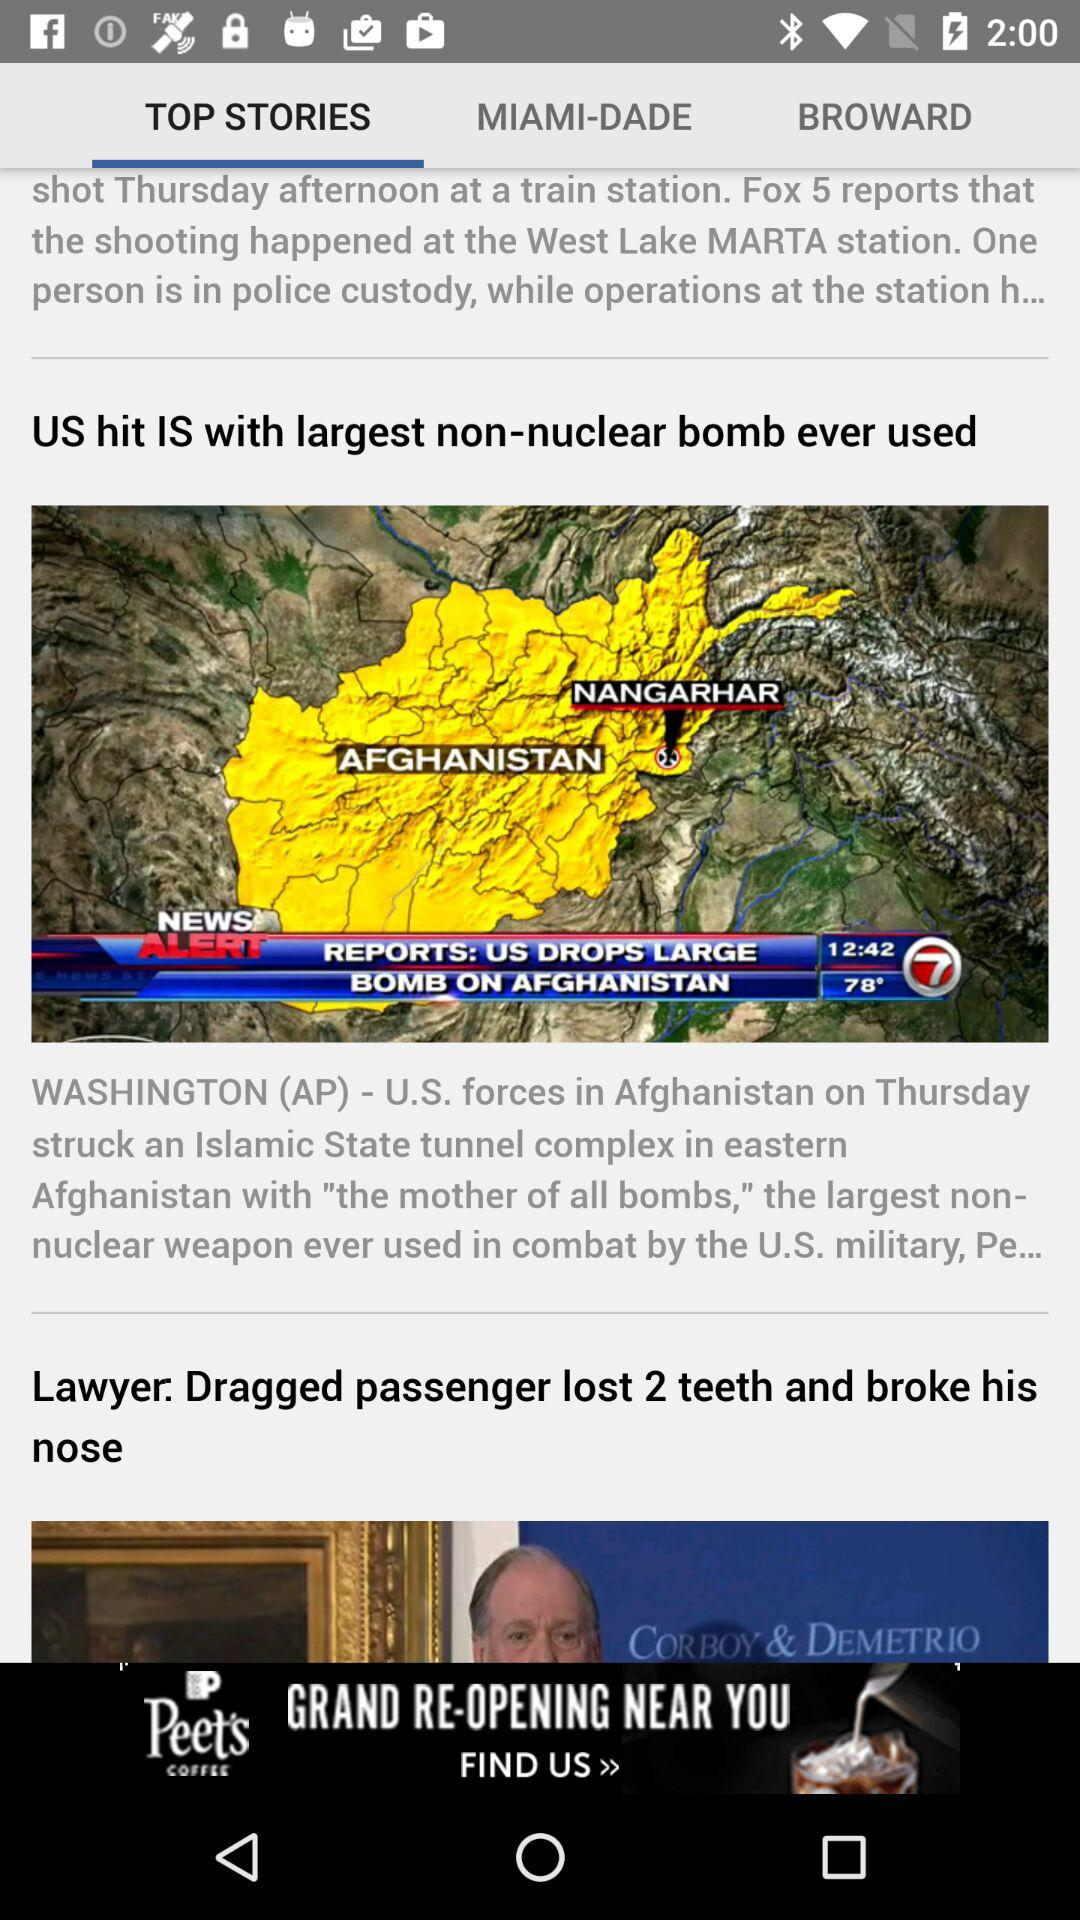Where is the given location of the article? The given location of the article is Washington (AP). 